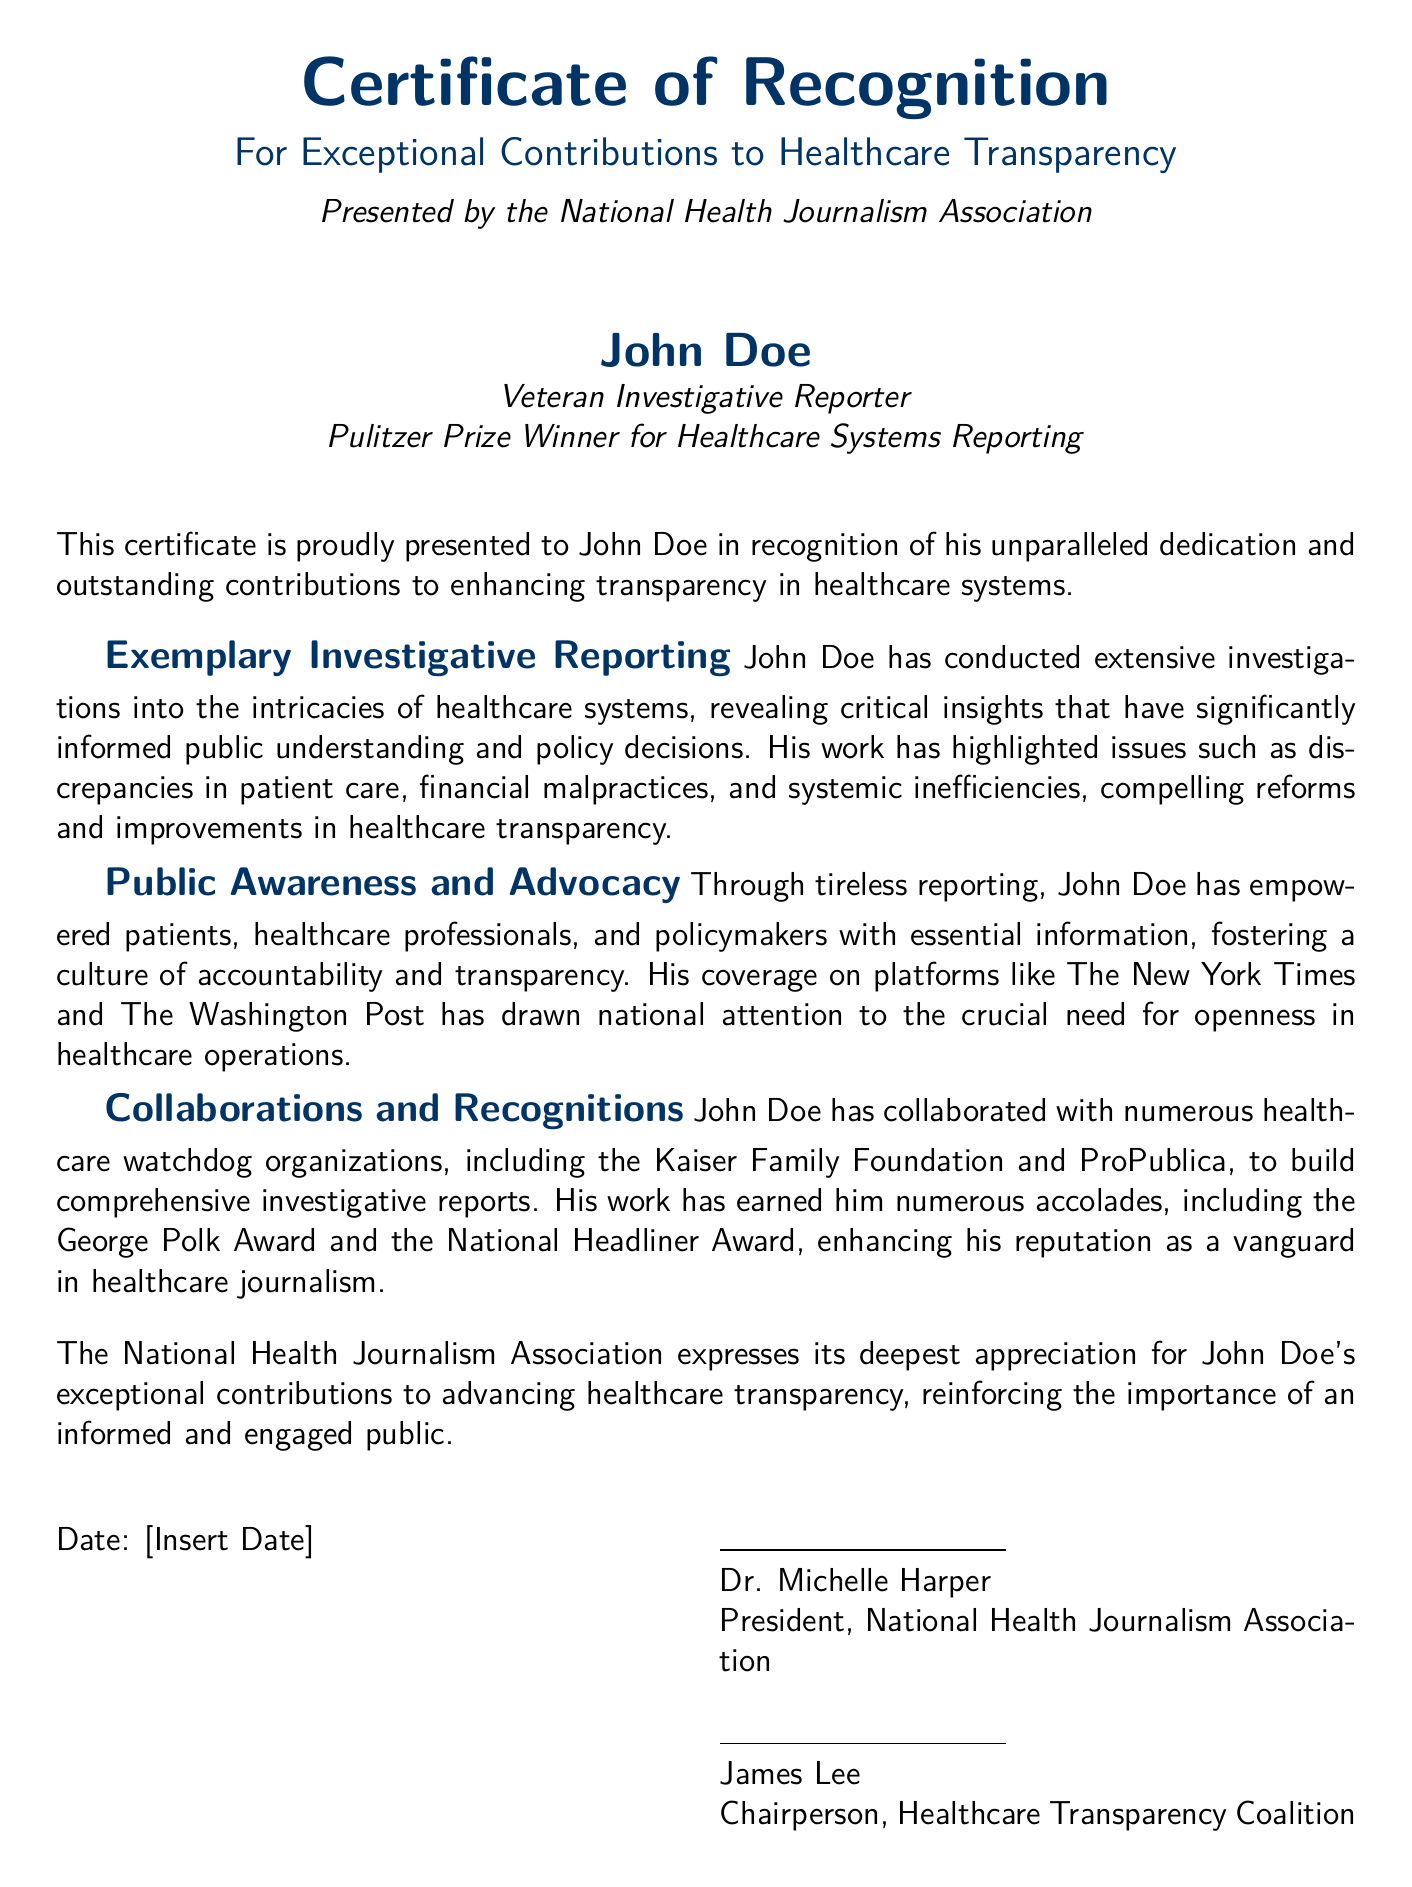What is the name of the person recognized in the certificate? The certificate presents recognition to a specific individual, which is John Doe.
Answer: John Doe Who presented the certificate? The document states that the certificate was presented by an organization, specifically the National Health Journalism Association.
Answer: National Health Journalism Association What is John Doe's title? The document details the individual's professional title as mentioned below his name.
Answer: Veteran Investigative Reporter Which major award has John Doe won? The document notes a specific accolade awarded to John Doe for his investigative work in healthcare systems.
Answer: Pulitzer Prize What organization does Dr. Michelle Harper represent? The document identifies the affiliation of Dr. Michelle Harper as the President of a specific organization.
Answer: National Health Journalism Association What is highlighted as a major focus of John Doe's reporting? The text outlines key themes within John Doe's work, one of which is specifically related to malpractice issues.
Answer: Financial malpractices Which award is mentioned alongside the Pulitzer Prize? The document lists additional recognitions, one being the George Polk Award, awarded for contributions to a field.
Answer: George Polk Award What quality is emphasized about John Doe's contributions to healthcare? The certificate describes John Doe's contributions in terms of a specific value related to healthcare systems.
Answer: Transparency What is the date section labeled as in the certificate? The certificate provides a space for a date but does not list a specific one, labeling it simply.
Answer: Date 